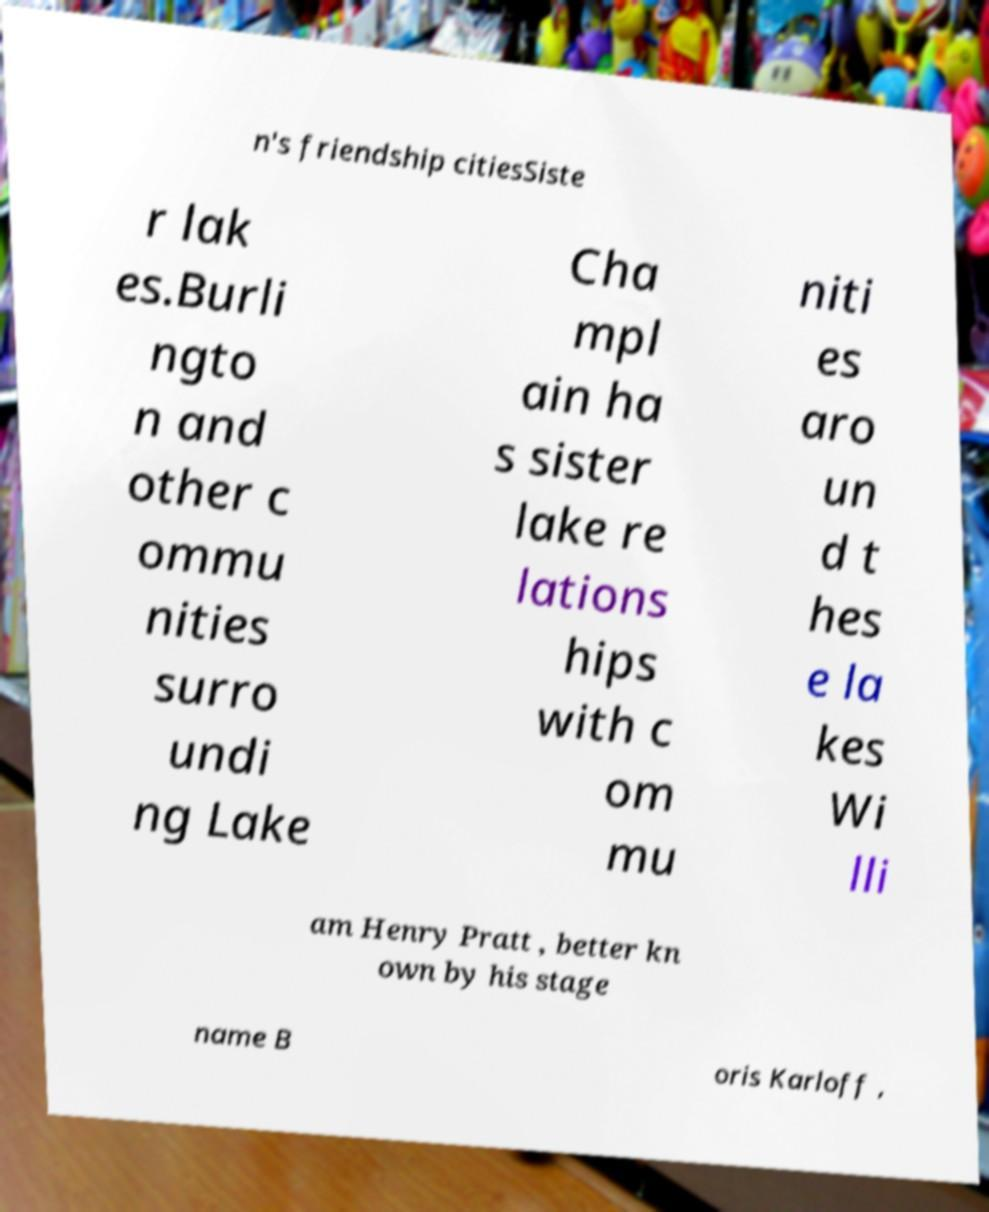Please read and relay the text visible in this image. What does it say? n's friendship citiesSiste r lak es.Burli ngto n and other c ommu nities surro undi ng Lake Cha mpl ain ha s sister lake re lations hips with c om mu niti es aro un d t hes e la kes Wi lli am Henry Pratt , better kn own by his stage name B oris Karloff , 